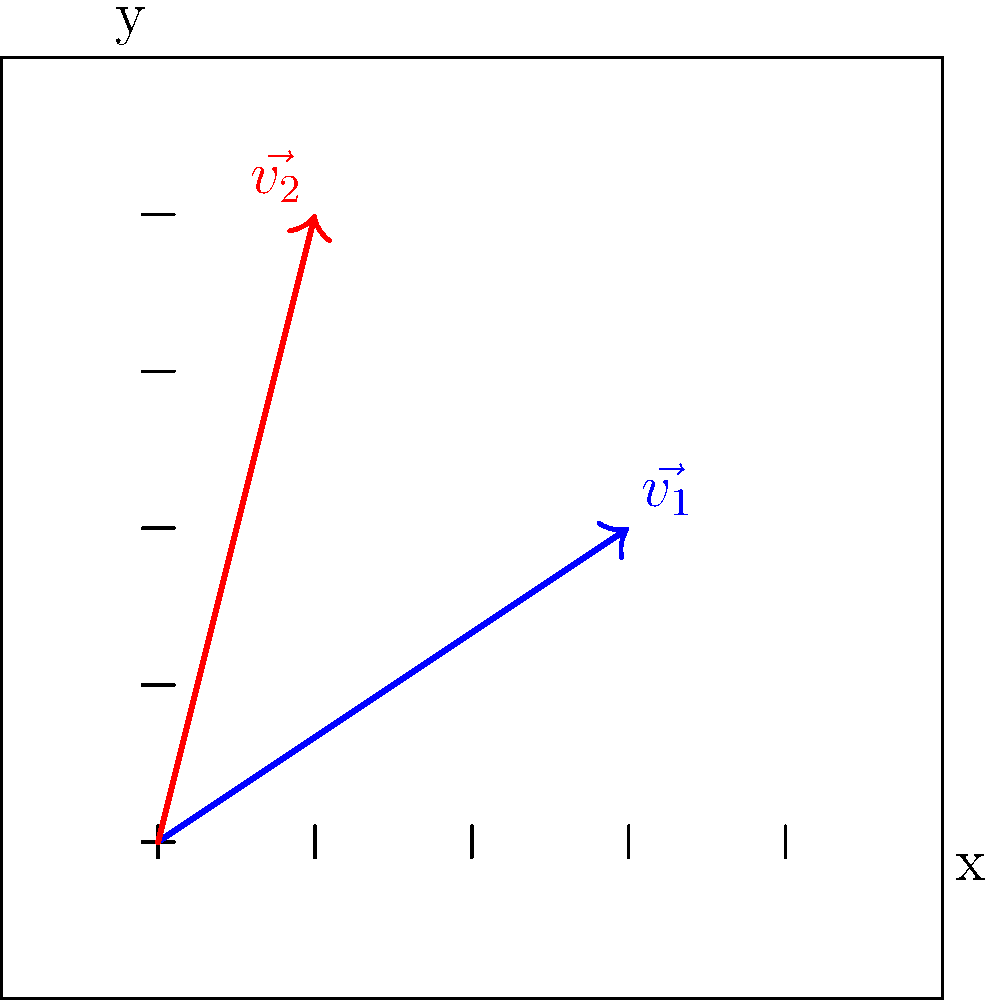As a tattoo artist, you're experimenting with different line styles represented by vectors. Vector $\vec{v_1}$ represents a bold line style with components (3, 2), while $\vec{v_2}$ represents a fine line style with components (1, 4). Calculate the dot product of these two vectors to determine their similarity in terms of style intensity. To calculate the dot product of two vectors, we multiply their corresponding components and sum the results. Let's break it down step-by-step:

1. Identify the components of each vector:
   $\vec{v_1} = (3, 2)$
   $\vec{v_2} = (1, 4)$

2. Multiply the corresponding components:
   x-components: $3 \times 1 = 3$
   y-components: $2 \times 4 = 8$

3. Sum the results:
   $\vec{v_1} \cdot \vec{v_2} = 3 + 8 = 11$

The dot product of $\vec{v_1}$ and $\vec{v_2}$ is 11, which represents the similarity in style intensity between the bold and fine line styles. A higher value indicates more similarity in terms of overall intensity, while a lower value would suggest more contrasting styles.
Answer: 11 